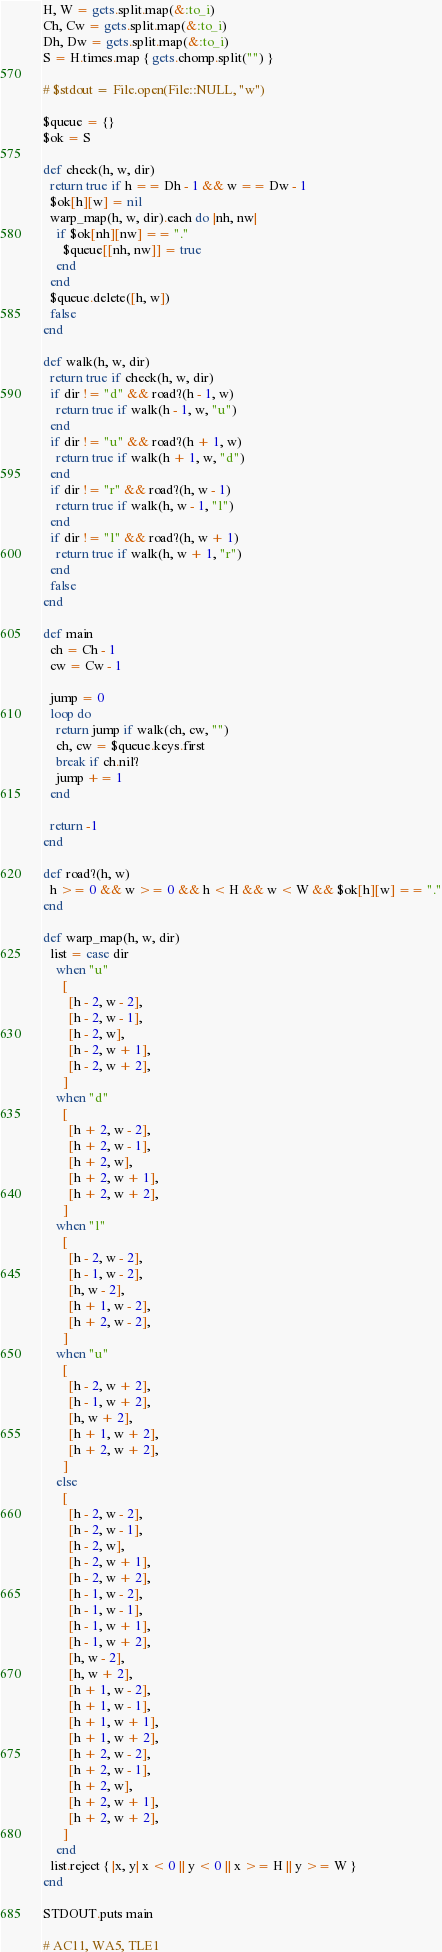Convert code to text. <code><loc_0><loc_0><loc_500><loc_500><_Ruby_>H, W = gets.split.map(&:to_i)
Ch, Cw = gets.split.map(&:to_i)
Dh, Dw = gets.split.map(&:to_i)
S = H.times.map { gets.chomp.split("") }

# $stdout = File.open(File::NULL, "w")

$queue = {}
$ok = S

def check(h, w, dir)
  return true if h == Dh - 1 && w == Dw - 1
  $ok[h][w] = nil
  warp_map(h, w, dir).each do |nh, nw|
    if $ok[nh][nw] == "."
      $queue[[nh, nw]] = true
    end
  end
  $queue.delete([h, w])
  false
end

def walk(h, w, dir)
  return true if check(h, w, dir)
  if dir != "d" && road?(h - 1, w)
    return true if walk(h - 1, w, "u")
  end
  if dir != "u" && road?(h + 1, w)
    return true if walk(h + 1, w, "d")
  end
  if dir != "r" && road?(h, w - 1)
    return true if walk(h, w - 1, "l")
  end
  if dir != "l" && road?(h, w + 1)
    return true if walk(h, w + 1, "r")
  end
  false
end

def main
  ch = Ch - 1
  cw = Cw - 1

  jump = 0
  loop do
    return jump if walk(ch, cw, "")
    ch, cw = $queue.keys.first
    break if ch.nil?
    jump += 1
  end

  return -1
end

def road?(h, w)
  h >= 0 && w >= 0 && h < H && w < W && $ok[h][w] == "."
end

def warp_map(h, w, dir)
  list = case dir
    when "u"
      [
        [h - 2, w - 2],
        [h - 2, w - 1],
        [h - 2, w],
        [h - 2, w + 1],
        [h - 2, w + 2],
      ]
    when "d"
      [
        [h + 2, w - 2],
        [h + 2, w - 1],
        [h + 2, w],
        [h + 2, w + 1],
        [h + 2, w + 2],
      ]
    when "l"
      [
        [h - 2, w - 2],
        [h - 1, w - 2],
        [h, w - 2],
        [h + 1, w - 2],
        [h + 2, w - 2],
      ]
    when "u"
      [
        [h - 2, w + 2],
        [h - 1, w + 2],
        [h, w + 2],
        [h + 1, w + 2],
        [h + 2, w + 2],
      ]
    else
      [
        [h - 2, w - 2],
        [h - 2, w - 1],
        [h - 2, w],
        [h - 2, w + 1],
        [h - 2, w + 2],
        [h - 1, w - 2],
        [h - 1, w - 1],
        [h - 1, w + 1],
        [h - 1, w + 2],
        [h, w - 2],
        [h, w + 2],
        [h + 1, w - 2],
        [h + 1, w - 1],
        [h + 1, w + 1],
        [h + 1, w + 2],
        [h + 2, w - 2],
        [h + 2, w - 1],
        [h + 2, w],
        [h + 2, w + 1],
        [h + 2, w + 2],
      ]
    end
  list.reject { |x, y| x < 0 || y < 0 || x >= H || y >= W }
end

STDOUT.puts main

# AC11, WA5, TLE1
</code> 